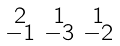Convert formula to latex. <formula><loc_0><loc_0><loc_500><loc_500>\begin{smallmatrix} 2 & 1 & 1 \\ - 1 & - 3 & - 2 \end{smallmatrix}</formula> 